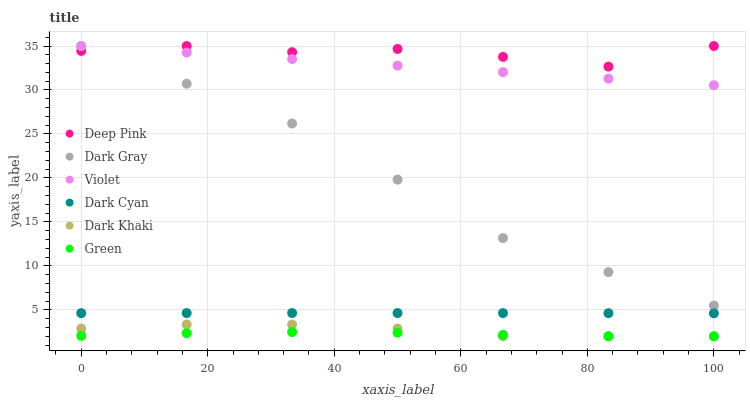Does Green have the minimum area under the curve?
Answer yes or no. Yes. Does Deep Pink have the maximum area under the curve?
Answer yes or no. Yes. Does Dark Gray have the minimum area under the curve?
Answer yes or no. No. Does Dark Gray have the maximum area under the curve?
Answer yes or no. No. Is Violet the smoothest?
Answer yes or no. Yes. Is Deep Pink the roughest?
Answer yes or no. Yes. Is Dark Gray the smoothest?
Answer yes or no. No. Is Dark Gray the roughest?
Answer yes or no. No. Does Dark Khaki have the lowest value?
Answer yes or no. Yes. Does Dark Gray have the lowest value?
Answer yes or no. No. Does Violet have the highest value?
Answer yes or no. Yes. Does Green have the highest value?
Answer yes or no. No. Is Dark Cyan less than Dark Gray?
Answer yes or no. Yes. Is Violet greater than Dark Khaki?
Answer yes or no. Yes. Does Violet intersect Dark Gray?
Answer yes or no. Yes. Is Violet less than Dark Gray?
Answer yes or no. No. Is Violet greater than Dark Gray?
Answer yes or no. No. Does Dark Cyan intersect Dark Gray?
Answer yes or no. No. 